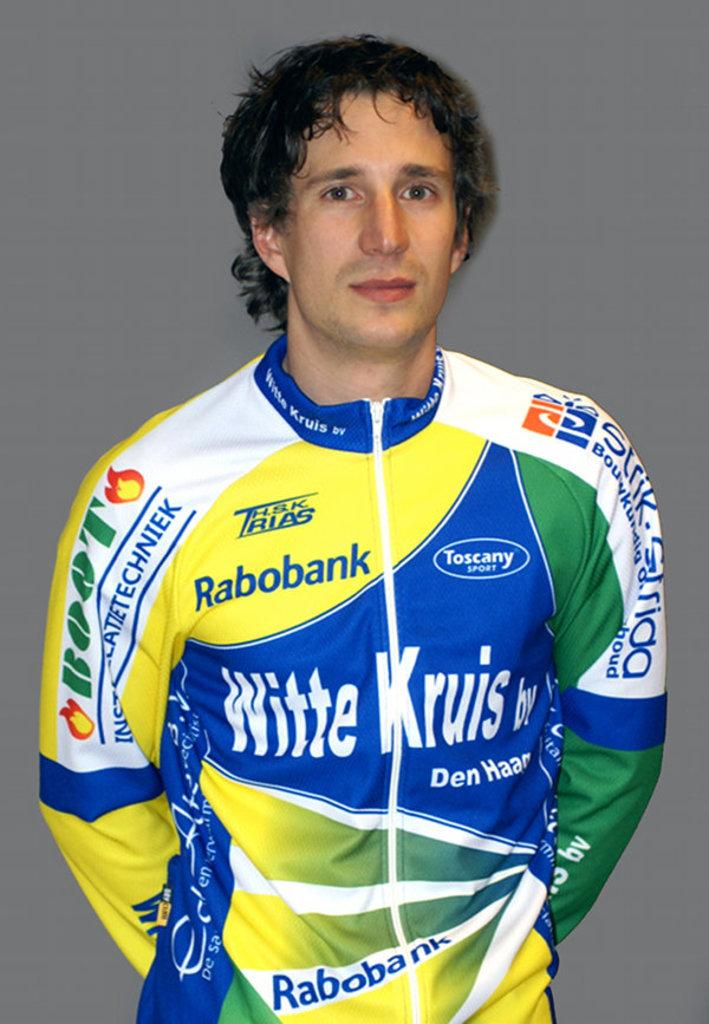<image>
Provide a brief description of the given image. An auto racer's uniform is covered in ads for Rabobank and Toscany Sport, among others. 